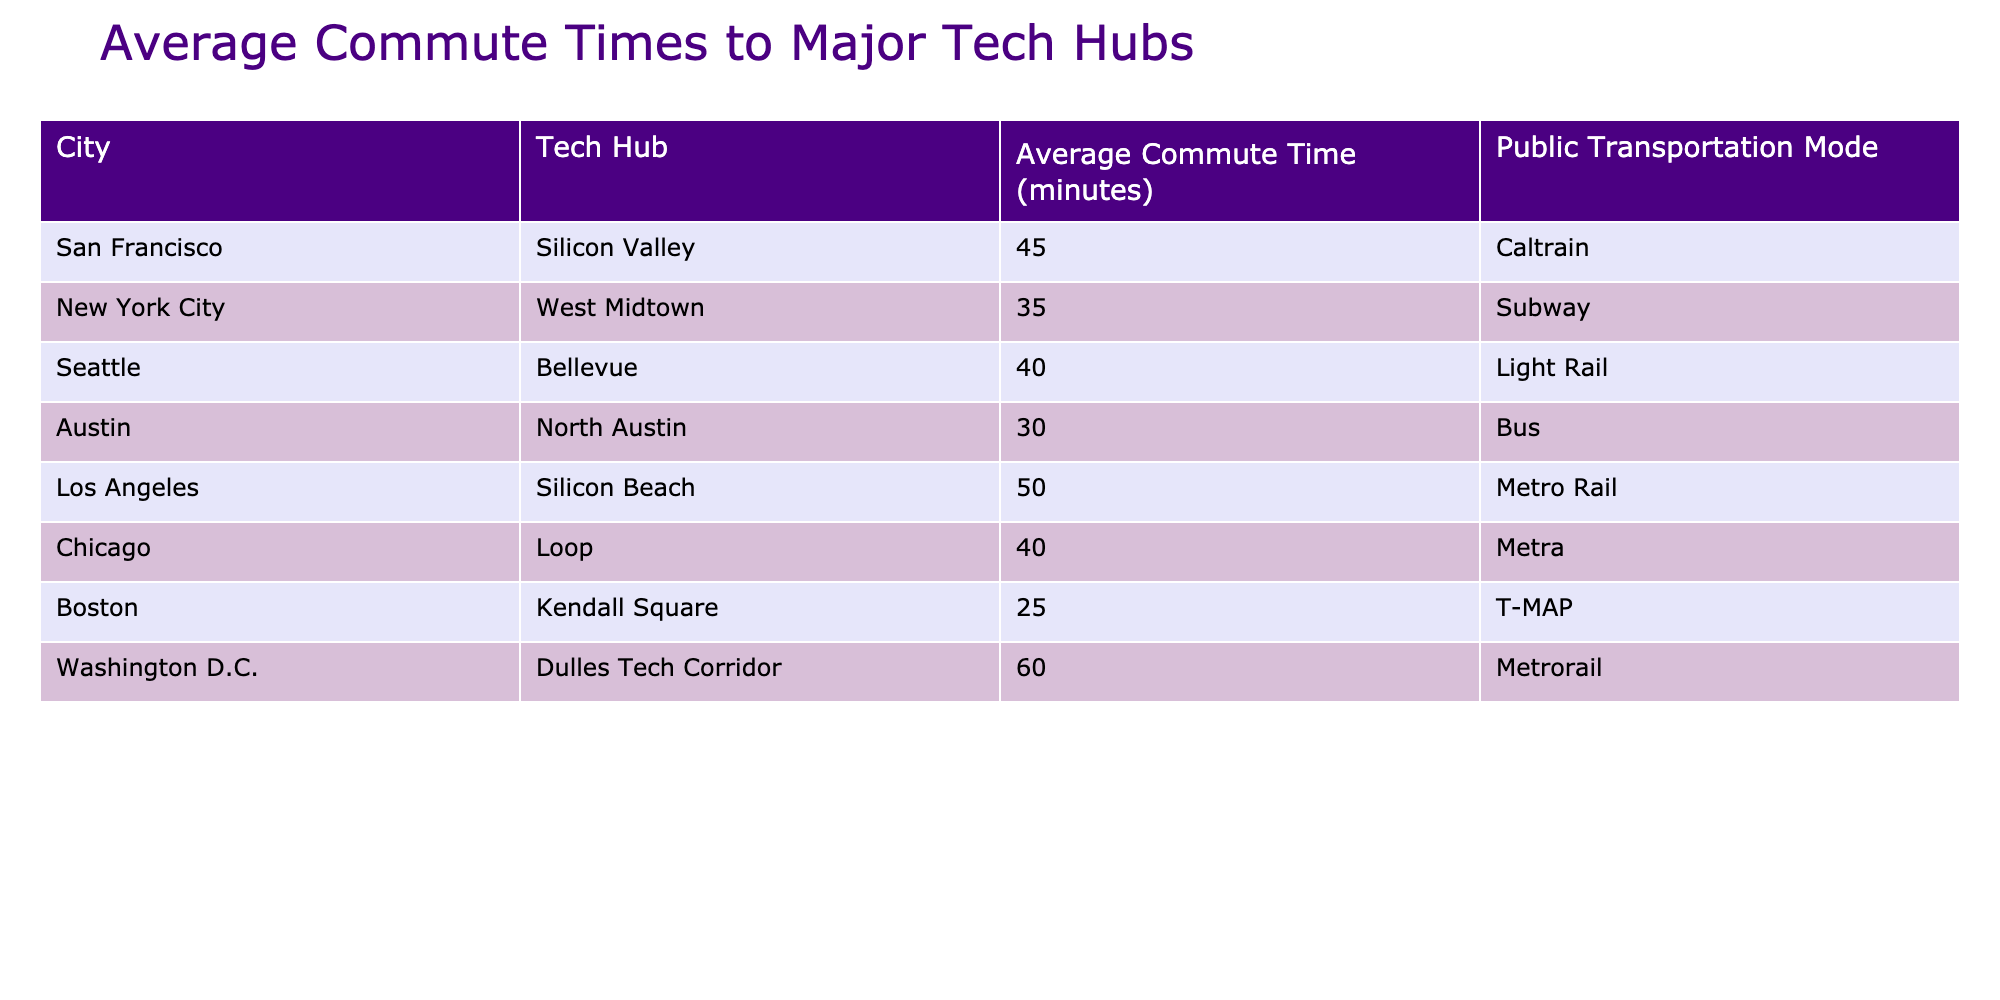What is the average commute time from San Francisco to Silicon Valley? The table shows that the average commute time from San Francisco to Silicon Valley is listed as 45 minutes in the respective row.
Answer: 45 minutes Which city's average commute time to its tech hub is the shortest? By examining the average commute times of all cities listed, Boston's Kendall Square has the shortest average commute time of 25 minutes.
Answer: Boston How many minutes longer does it take to commute to Dulles Tech Corridor compared to Kendall Square? The average commute time to Dulles Tech Corridor is 60 minutes, while its time to Kendall Square is 25 minutes. To find the difference, subtract: 60 - 25 = 35 minutes.
Answer: 35 minutes Is the average commute time from Chicago to Loop greater than the average commute time from Austin to North Austin? The average commute time to Loop in Chicago is 40 minutes, while the time to North Austin in Austin is 30 minutes. Since 40 is greater than 30, the answer is yes.
Answer: Yes What would be the average commute time if we combine all the listed average commute times? To calculate the average, first sum all the average times: 45 + 35 + 40 + 30 + 50 + 40 + 25 + 60 = 320. Then, divide by the number of cities, which is 8: 320 / 8 = 40 minutes.
Answer: 40 minutes In which city is the Metro Rail used for commuting to its tech hub? The table indicates that Los Angeles uses Metro Rail for commuting to Silicon Beach. This information comes directly from the mode of transport listed for that row.
Answer: Los Angeles Are there more cities with an average commute time above 40 minutes than below? By counting the commute times, we find that there are four cities (Silicon Valley, Silicon Beach, Dulles Tech Corridor, and Loop) with times above 40 minutes, and four cities (North Austin, Kendall Square, and two others) with times below 40 minutes. Since both have equal counts, the answer is no.
Answer: No What is the total average commute time of the cities that use public transportation by bus? Austin, which uses a bus, has an average commute time of 30 minutes. The total for bus users is thus just this one value, as it is the only one in the list.
Answer: 30 minutes Which public transportation mode has the longest average commute time among the cities listed? In the table, the Metrorail in Washington D.C. is noted to have the longest average commute time at 60 minutes. This can be confirmed by comparing all modes in the table to find the maximum value.
Answer: Metrorail 